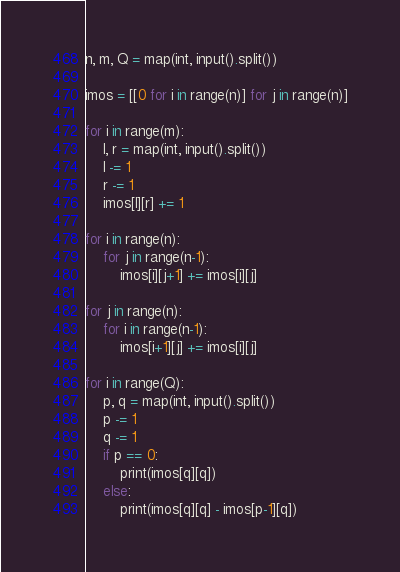<code> <loc_0><loc_0><loc_500><loc_500><_Python_>n, m, Q = map(int, input().split())

imos = [[0 for i in range(n)] for j in range(n)]

for i in range(m):
    l, r = map(int, input().split())
    l -= 1
    r -= 1
    imos[l][r] += 1

for i in range(n):
    for j in range(n-1):
        imos[i][j+1] += imos[i][j]

for j in range(n):
    for i in range(n-1):
        imos[i+1][j] += imos[i][j]

for i in range(Q):
    p, q = map(int, input().split())
    p -= 1
    q -= 1
    if p == 0:
        print(imos[q][q])
    else:
        print(imos[q][q] - imos[p-1][q])
</code> 